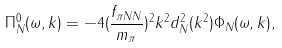Convert formula to latex. <formula><loc_0><loc_0><loc_500><loc_500>\Pi ^ { 0 } _ { N } ( \omega , k ) = - 4 ( \frac { f _ { \pi N N } } { m _ { \pi } } ) ^ { 2 } k ^ { 2 } d ^ { 2 } _ { N } ( k ^ { 2 } ) \Phi _ { N } ( \omega , k ) ,</formula> 